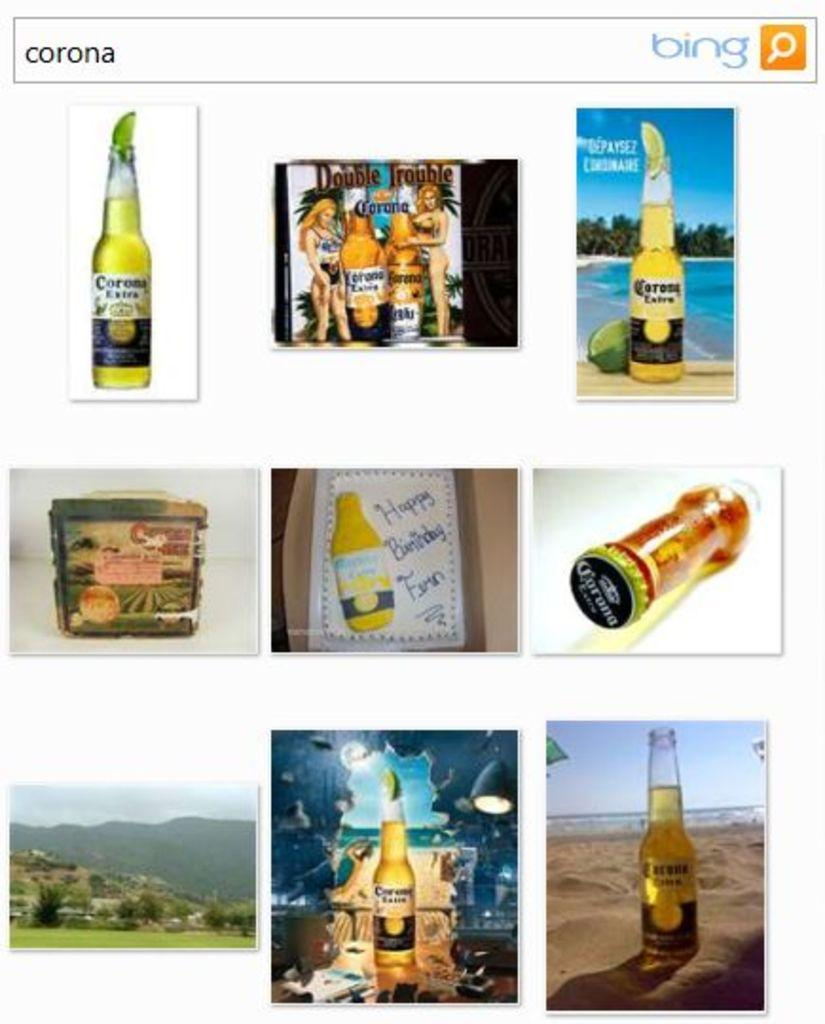Provide a one-sentence caption for the provided image. Search screen for corona that shows many photos of Corona. 